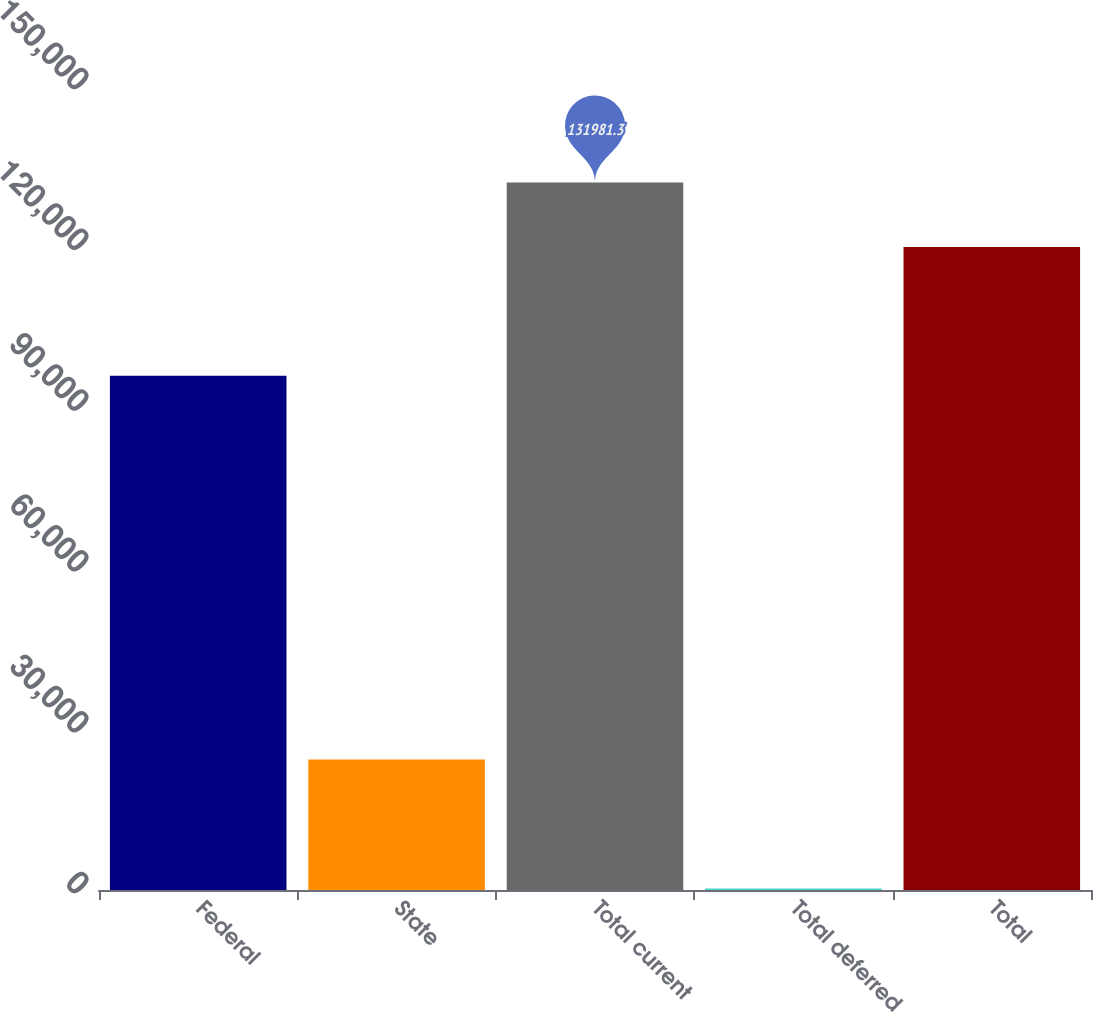Convert chart. <chart><loc_0><loc_0><loc_500><loc_500><bar_chart><fcel>Federal<fcel>State<fcel>Total current<fcel>Total deferred<fcel>Total<nl><fcel>95946<fcel>24327<fcel>131981<fcel>290<fcel>119983<nl></chart> 